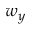Convert formula to latex. <formula><loc_0><loc_0><loc_500><loc_500>w _ { y }</formula> 